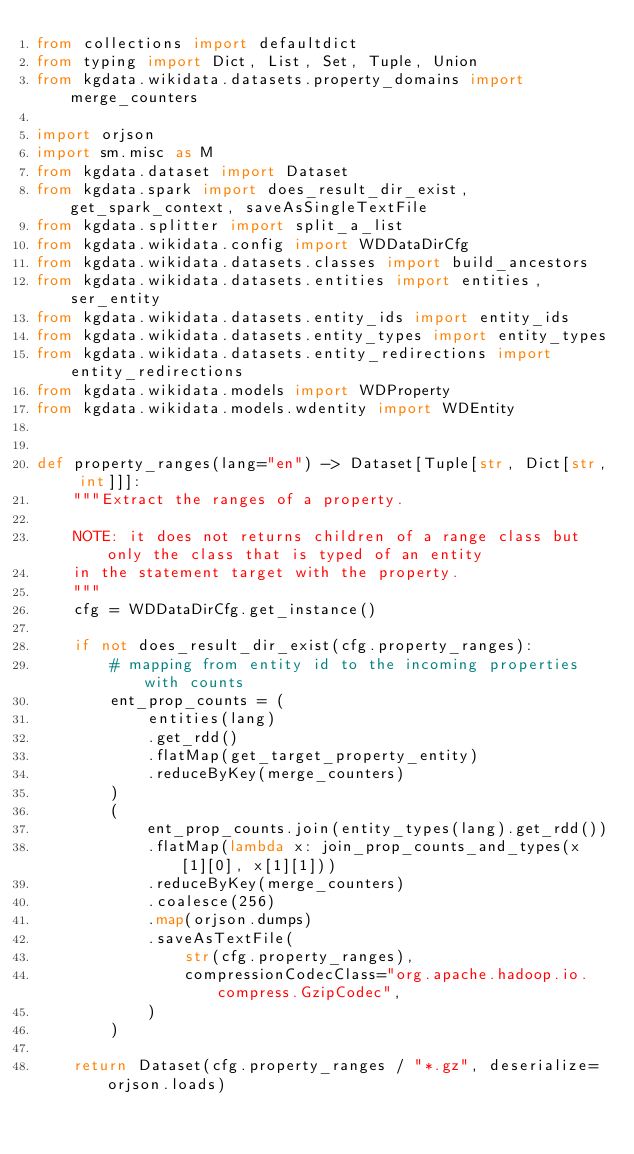<code> <loc_0><loc_0><loc_500><loc_500><_Python_>from collections import defaultdict
from typing import Dict, List, Set, Tuple, Union
from kgdata.wikidata.datasets.property_domains import merge_counters

import orjson
import sm.misc as M
from kgdata.dataset import Dataset
from kgdata.spark import does_result_dir_exist, get_spark_context, saveAsSingleTextFile
from kgdata.splitter import split_a_list
from kgdata.wikidata.config import WDDataDirCfg
from kgdata.wikidata.datasets.classes import build_ancestors
from kgdata.wikidata.datasets.entities import entities, ser_entity
from kgdata.wikidata.datasets.entity_ids import entity_ids
from kgdata.wikidata.datasets.entity_types import entity_types
from kgdata.wikidata.datasets.entity_redirections import entity_redirections
from kgdata.wikidata.models import WDProperty
from kgdata.wikidata.models.wdentity import WDEntity


def property_ranges(lang="en") -> Dataset[Tuple[str, Dict[str, int]]]:
    """Extract the ranges of a property.

    NOTE: it does not returns children of a range class but only the class that is typed of an entity
    in the statement target with the property.
    """
    cfg = WDDataDirCfg.get_instance()

    if not does_result_dir_exist(cfg.property_ranges):
        # mapping from entity id to the incoming properties with counts
        ent_prop_counts = (
            entities(lang)
            .get_rdd()
            .flatMap(get_target_property_entity)
            .reduceByKey(merge_counters)
        )
        (
            ent_prop_counts.join(entity_types(lang).get_rdd())
            .flatMap(lambda x: join_prop_counts_and_types(x[1][0], x[1][1]))
            .reduceByKey(merge_counters)
            .coalesce(256)
            .map(orjson.dumps)
            .saveAsTextFile(
                str(cfg.property_ranges),
                compressionCodecClass="org.apache.hadoop.io.compress.GzipCodec",
            )
        )

    return Dataset(cfg.property_ranges / "*.gz", deserialize=orjson.loads)

</code> 